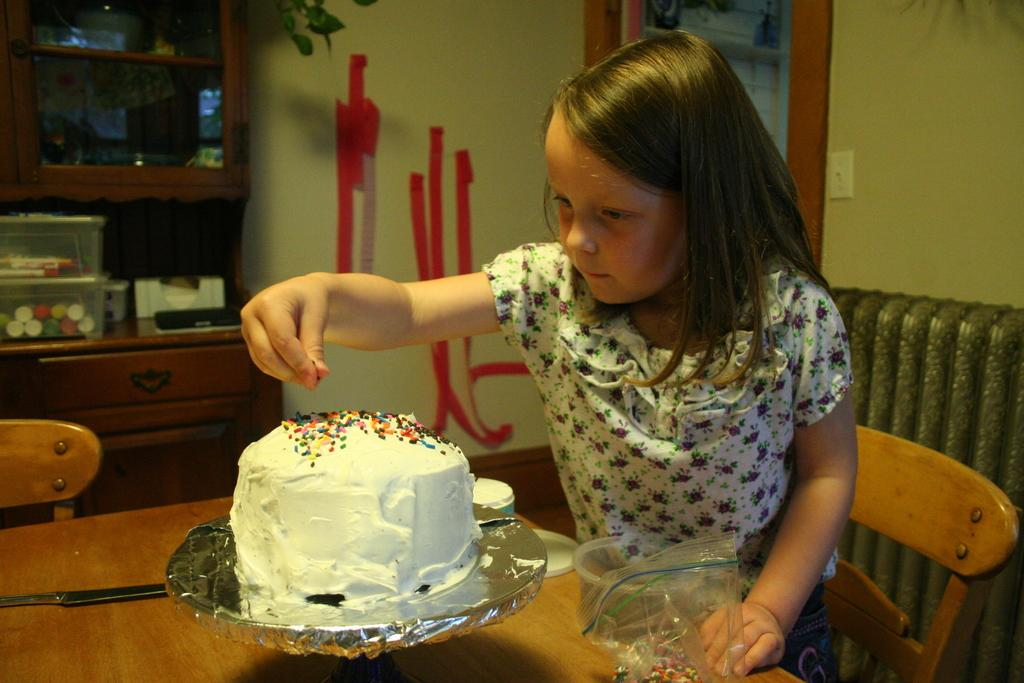What is the main piece of furniture in the image? There is a table in the image. What is placed on the table? There is a cake on the table. Who is present near the table? A child is sitting on a chair near the table. What can be seen in the background of the image? There is a wall and a cupboard in the background of the image. What type of cabbage is being used as a decoration on the cake? There is no cabbage present on the cake in the image. How many brothers does the child sitting near the table have? The provided facts do not mention any siblings, so we cannot determine the number of brothers the child has. 